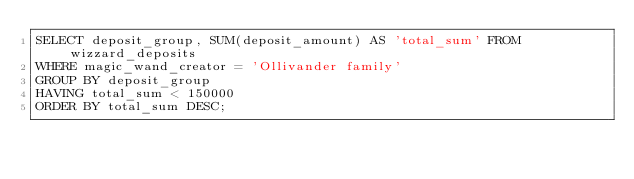<code> <loc_0><loc_0><loc_500><loc_500><_SQL_>SELECT deposit_group, SUM(deposit_amount) AS 'total_sum' FROM wizzard_deposits
WHERE magic_wand_creator = 'Ollivander family'
GROUP BY deposit_group
HAVING total_sum < 150000
ORDER BY total_sum DESC;</code> 